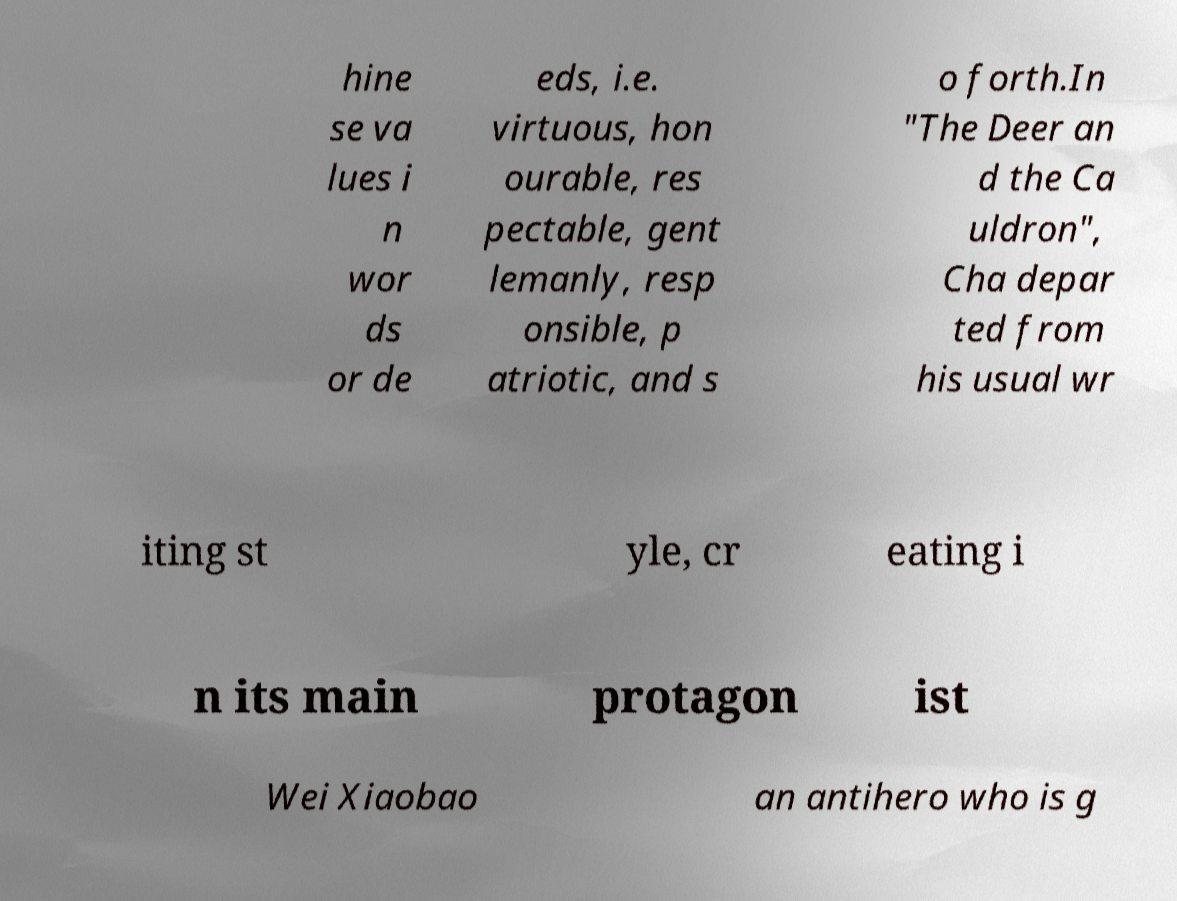Please identify and transcribe the text found in this image. hine se va lues i n wor ds or de eds, i.e. virtuous, hon ourable, res pectable, gent lemanly, resp onsible, p atriotic, and s o forth.In "The Deer an d the Ca uldron", Cha depar ted from his usual wr iting st yle, cr eating i n its main protagon ist Wei Xiaobao an antihero who is g 